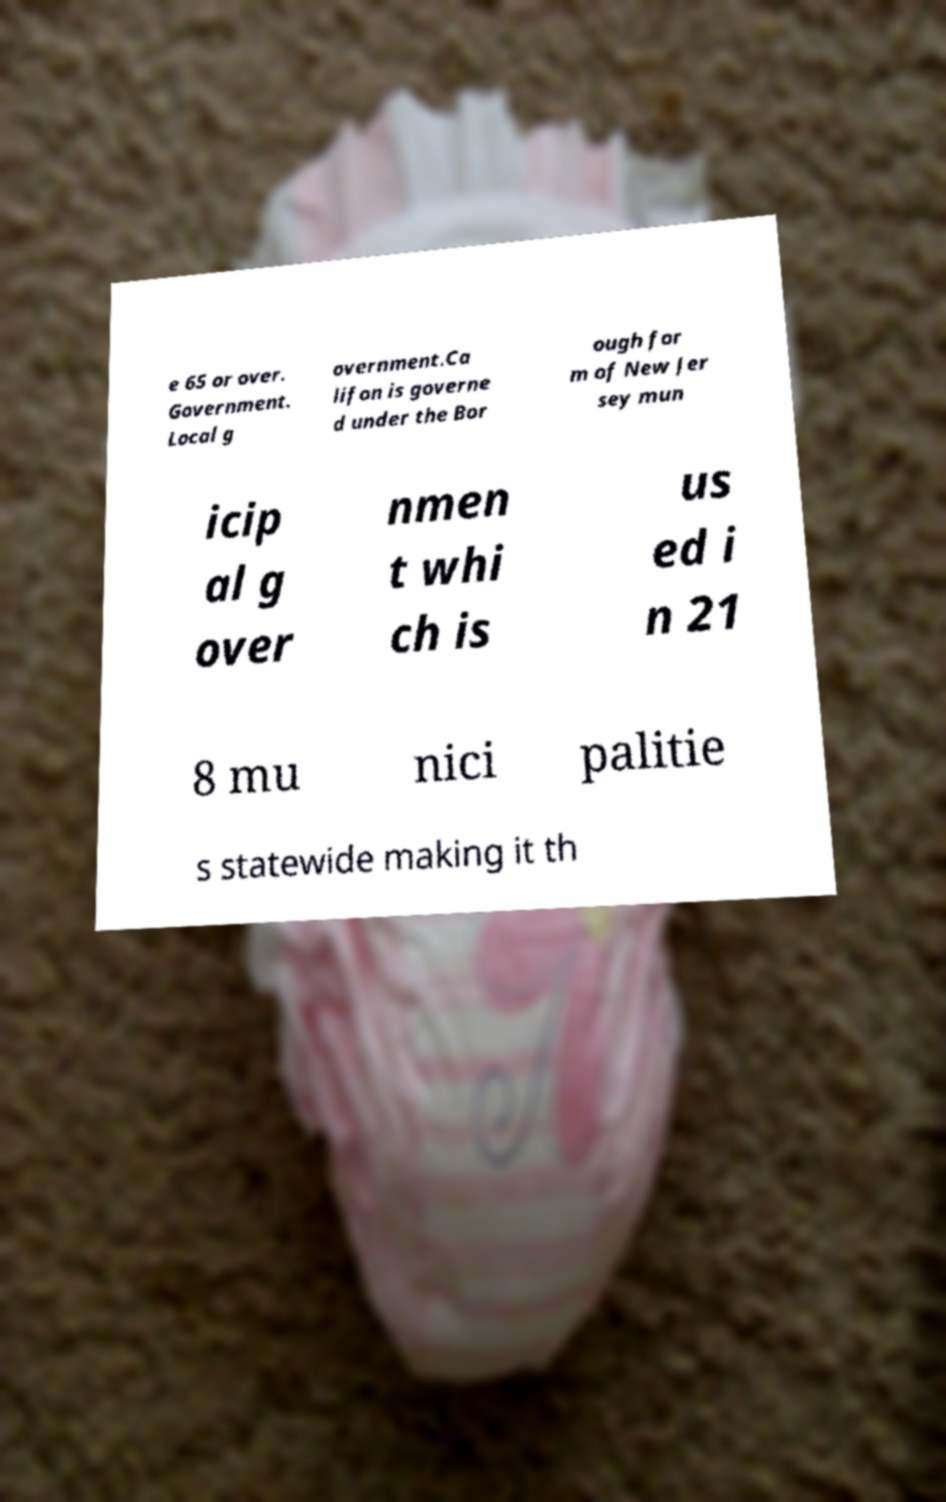Could you extract and type out the text from this image? e 65 or over. Government. Local g overnment.Ca lifon is governe d under the Bor ough for m of New Jer sey mun icip al g over nmen t whi ch is us ed i n 21 8 mu nici palitie s statewide making it th 